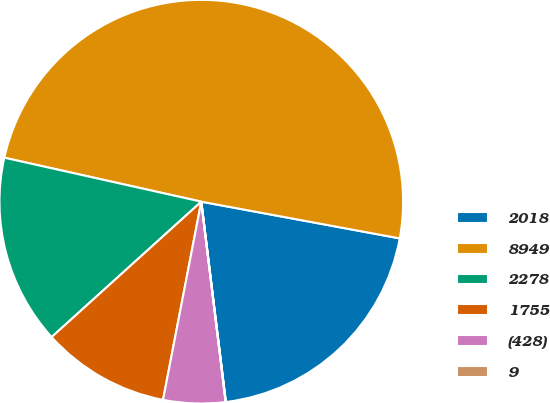<chart> <loc_0><loc_0><loc_500><loc_500><pie_chart><fcel>2018<fcel>8949<fcel>2278<fcel>1755<fcel>(428)<fcel>9<nl><fcel>20.14%<fcel>49.41%<fcel>15.2%<fcel>10.26%<fcel>4.96%<fcel>0.02%<nl></chart> 